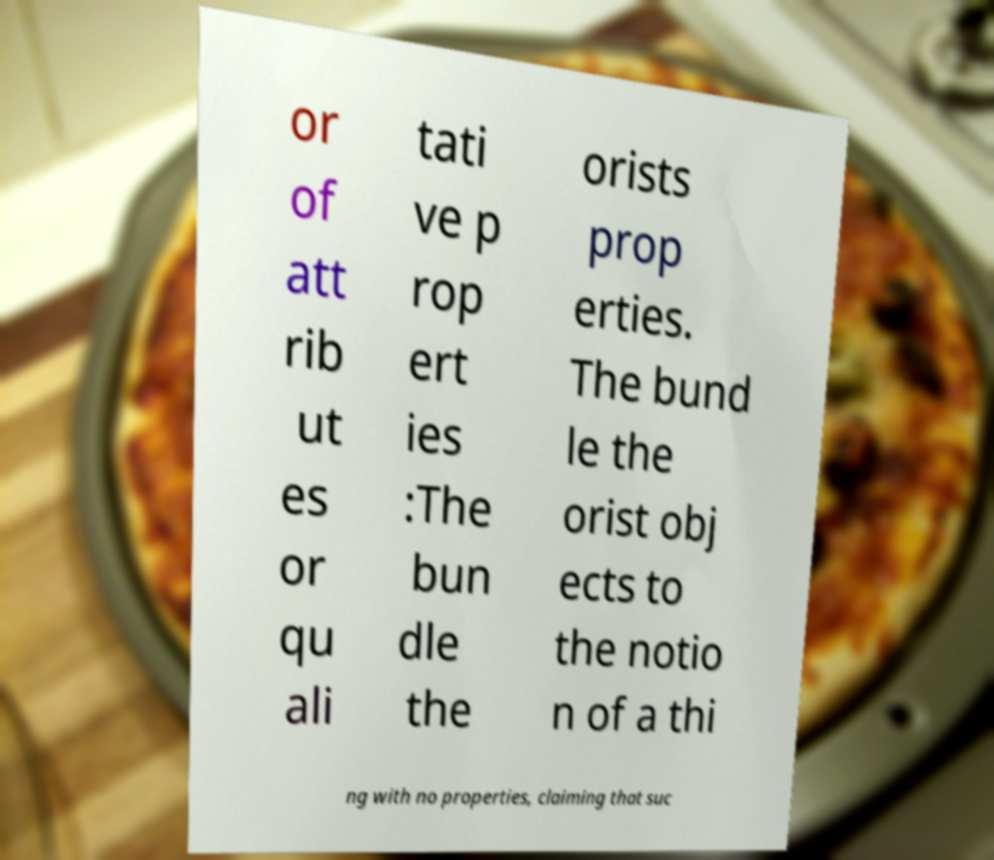Can you read and provide the text displayed in the image?This photo seems to have some interesting text. Can you extract and type it out for me? or of att rib ut es or qu ali tati ve p rop ert ies :The bun dle the orists prop erties. The bund le the orist obj ects to the notio n of a thi ng with no properties, claiming that suc 